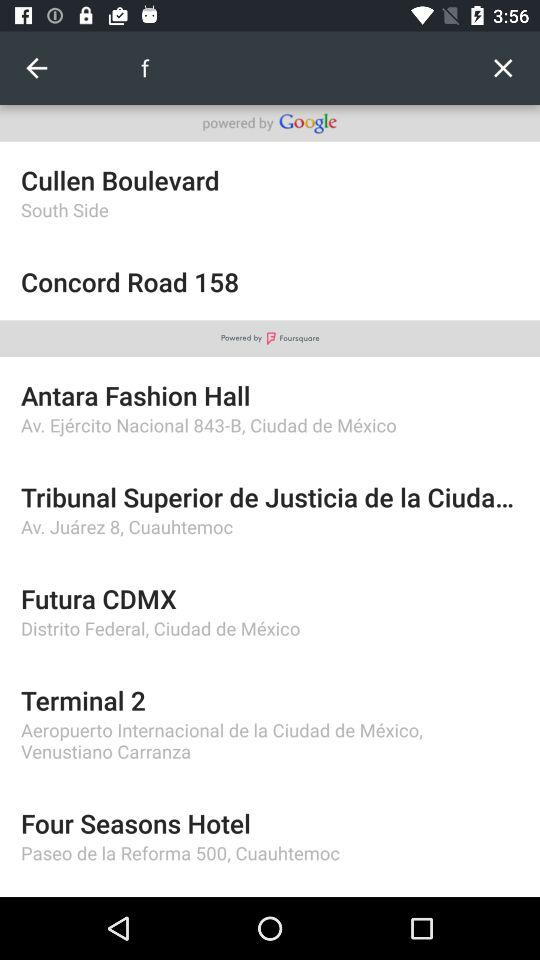On what side is "Cullen Boulevard"? "Cullen Boulevard" is on the south side. 